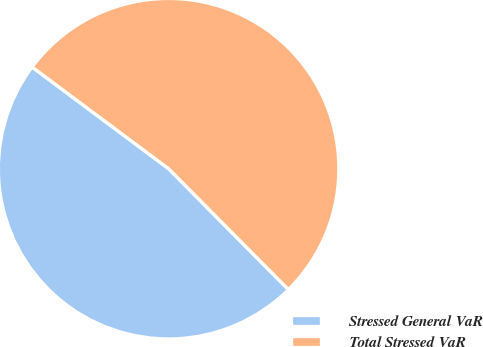Convert chart. <chart><loc_0><loc_0><loc_500><loc_500><pie_chart><fcel>Stressed General VaR<fcel>Total Stressed VaR<nl><fcel>47.62%<fcel>52.38%<nl></chart> 